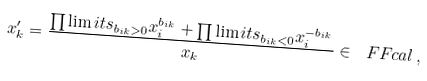Convert formula to latex. <formula><loc_0><loc_0><loc_500><loc_500>x ^ { \prime } _ { k } = \frac { \prod \lim i t s _ { b _ { i k } > 0 } x _ { i } ^ { b _ { i k } } + \prod \lim i t s _ { b _ { i k } < 0 } x _ { i } ^ { - b _ { i k } } } { x _ { k } } \in \ F F c a l \, ,</formula> 